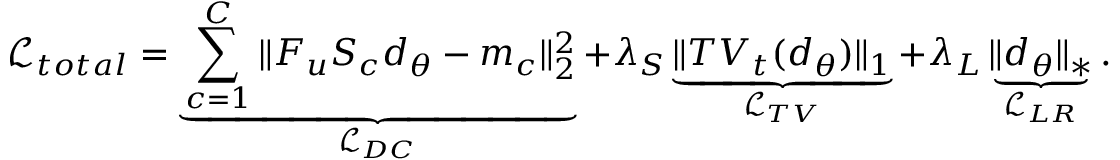<formula> <loc_0><loc_0><loc_500><loc_500>\mathcal { L } _ { t o t a l } = \underbrace { \sum _ { c = 1 } ^ { C } \| F _ { u } S _ { c } d _ { \theta } - m _ { c } \| _ { 2 } ^ { 2 } } _ { \mathcal { L } _ { D C } } + \lambda _ { S } \underbrace { \| T V _ { t } ( d _ { \theta } ) \| _ { 1 } } _ { \mathcal { L } _ { T V } } + \lambda _ { L } \underbrace { \| d _ { \theta } \| _ { * } } _ { \mathcal { L } _ { L R } } .</formula> 